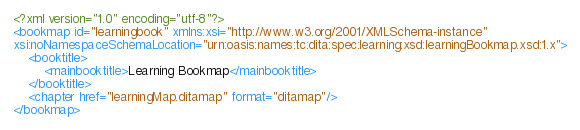Convert code to text. <code><loc_0><loc_0><loc_500><loc_500><_XML_><?xml version="1.0" encoding="utf-8"?>
<bookmap id="learningbook" xmlns:xsi="http://www.w3.org/2001/XMLSchema-instance"
xsi:noNamespaceSchemaLocation="urn:oasis:names:tc:dita:spec:learning:xsd:learningBookmap.xsd:1.x">
    <booktitle>
        <mainbooktitle>Learning Bookmap</mainbooktitle>
    </booktitle>
    <chapter href="learningMap.ditamap" format="ditamap"/>
</bookmap>
</code> 